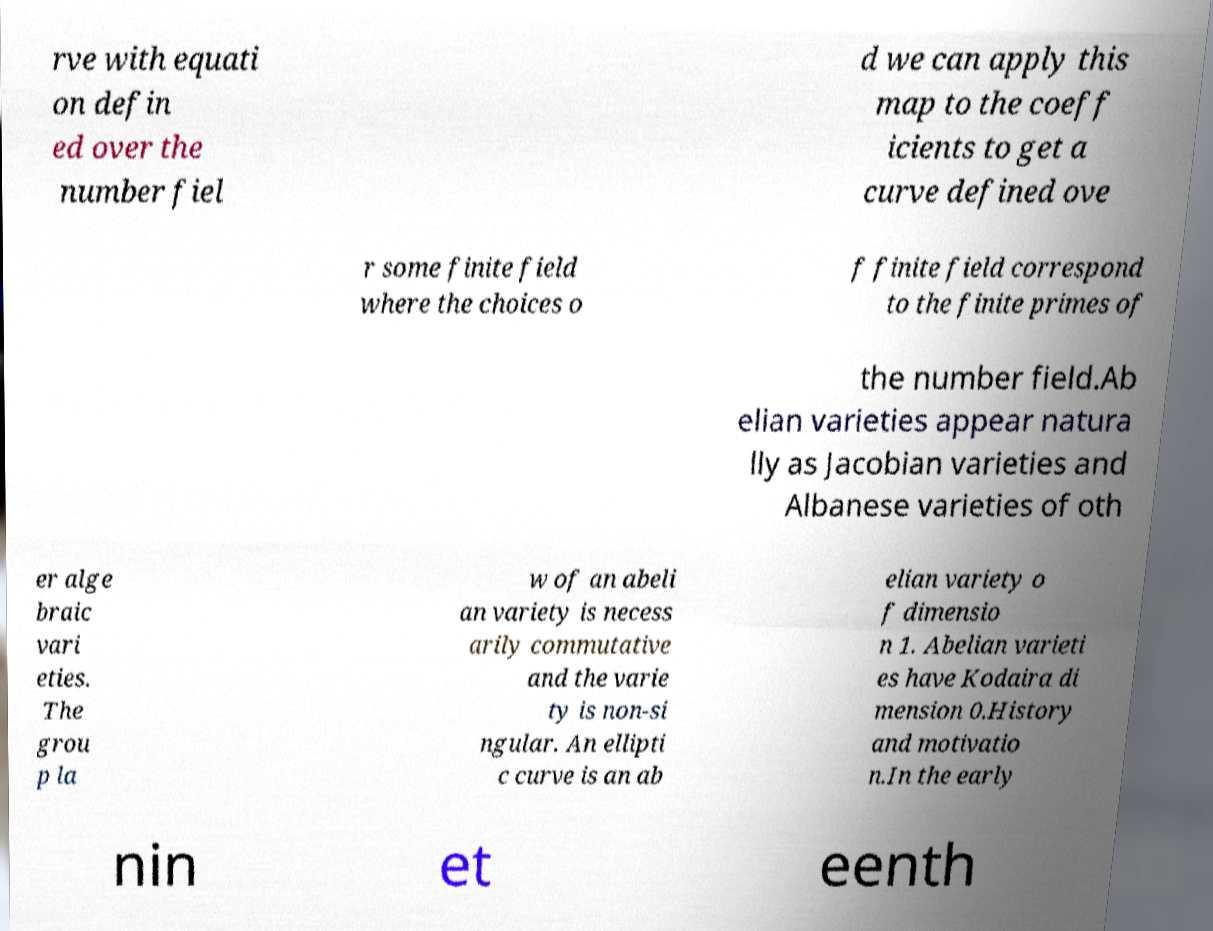Could you assist in decoding the text presented in this image and type it out clearly? rve with equati on defin ed over the number fiel d we can apply this map to the coeff icients to get a curve defined ove r some finite field where the choices o f finite field correspond to the finite primes of the number field.Ab elian varieties appear natura lly as Jacobian varieties and Albanese varieties of oth er alge braic vari eties. The grou p la w of an abeli an variety is necess arily commutative and the varie ty is non-si ngular. An ellipti c curve is an ab elian variety o f dimensio n 1. Abelian varieti es have Kodaira di mension 0.History and motivatio n.In the early nin et eenth 